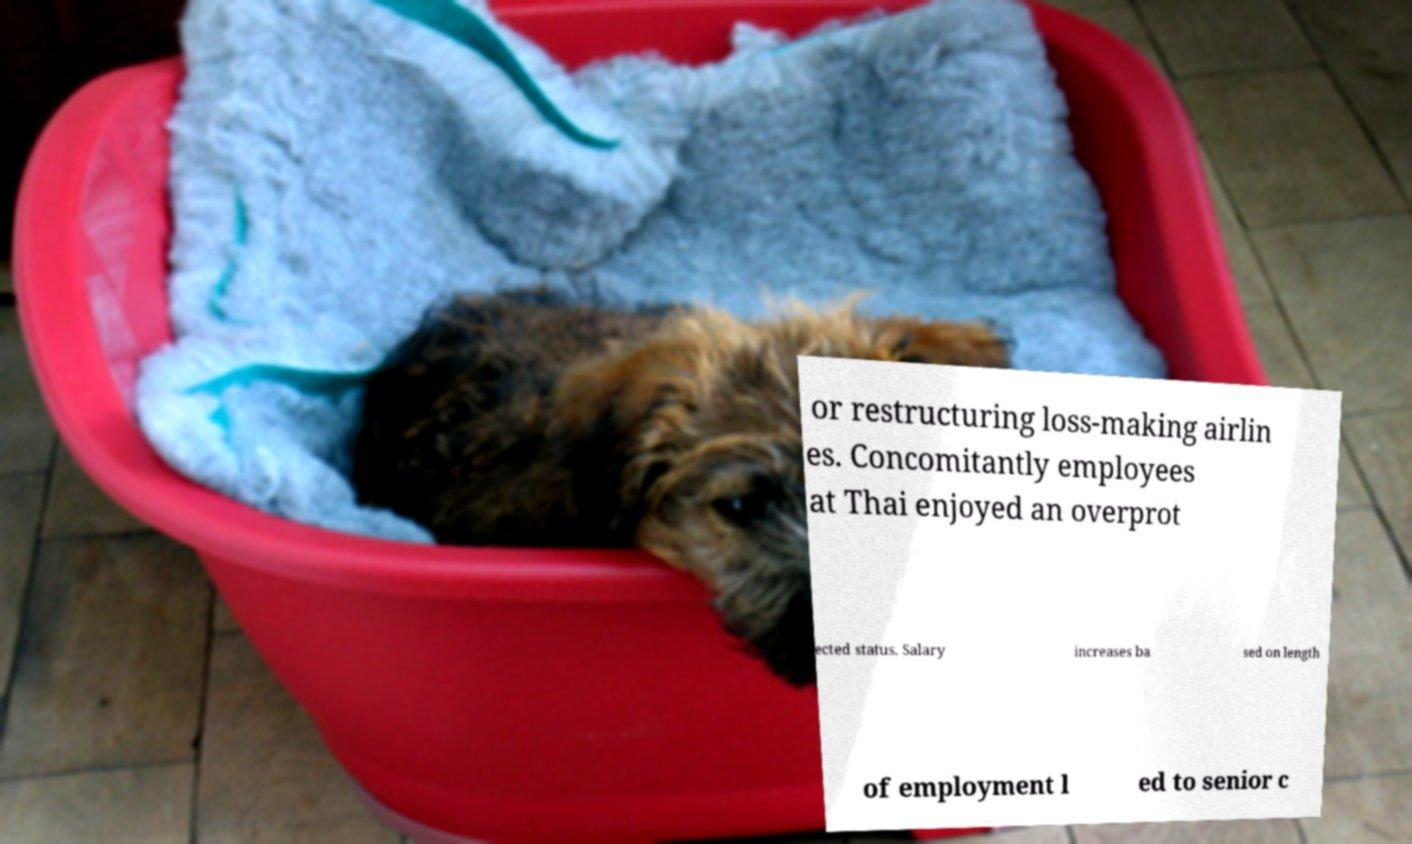What messages or text are displayed in this image? I need them in a readable, typed format. or restructuring loss-making airlin es. Concomitantly employees at Thai enjoyed an overprot ected status. Salary increases ba sed on length of employment l ed to senior c 